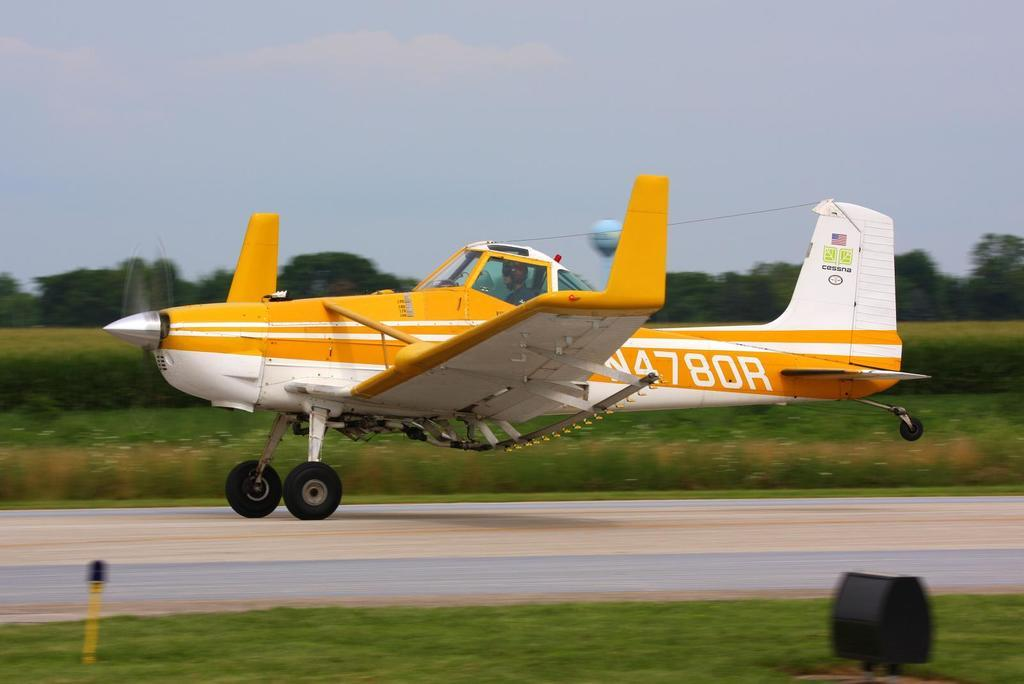What is the main subject of the image? There is an aeroplane on the image. Where is the aeroplane located in the image? The aeroplane is on the runway in the center of the image. What type of vegetation can be seen at the bottom of the image? Grass is visible at the bottom of the image. What can be seen in the background of the image? Trees, grass, plants, and the sky are visible in the background of the image. What type of chain is hanging from the aeroplane in the image? There is no chain hanging from the aeroplane in the image. What color is the underwear of the person standing next to the aeroplane in the image? There is no person standing next to the aeroplane in the image. 